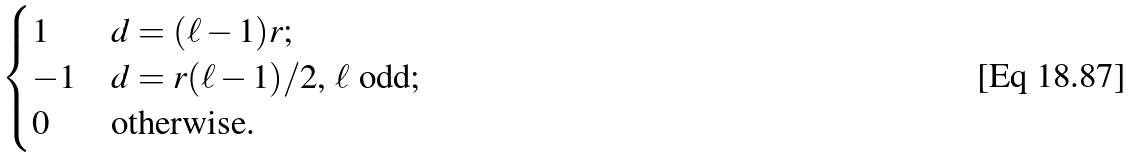Convert formula to latex. <formula><loc_0><loc_0><loc_500><loc_500>\begin{cases} 1 & \text {$d=({\ell}-1)r$;} \\ - 1 & \text {$d=r(\ell-1)/2$, $\ell$ odd;} \\ 0 & \text {otherwise.} \end{cases}</formula> 